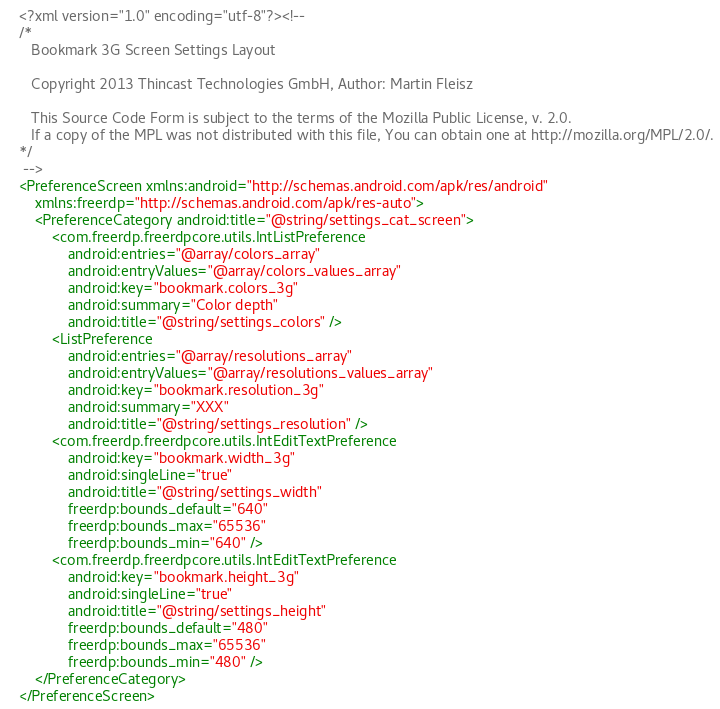<code> <loc_0><loc_0><loc_500><loc_500><_XML_><?xml version="1.0" encoding="utf-8"?><!--
/*
   Bookmark 3G Screen Settings Layout

   Copyright 2013 Thincast Technologies GmbH, Author: Martin Fleisz

   This Source Code Form is subject to the terms of the Mozilla Public License, v. 2.0. 
   If a copy of the MPL was not distributed with this file, You can obtain one at http://mozilla.org/MPL/2.0/.
*/
 -->
<PreferenceScreen xmlns:android="http://schemas.android.com/apk/res/android"
    xmlns:freerdp="http://schemas.android.com/apk/res-auto">
    <PreferenceCategory android:title="@string/settings_cat_screen">
        <com.freerdp.freerdpcore.utils.IntListPreference
            android:entries="@array/colors_array"
            android:entryValues="@array/colors_values_array"
            android:key="bookmark.colors_3g"
            android:summary="Color depth"
            android:title="@string/settings_colors" />
        <ListPreference
            android:entries="@array/resolutions_array"
            android:entryValues="@array/resolutions_values_array"
            android:key="bookmark.resolution_3g"
            android:summary="XXX"
            android:title="@string/settings_resolution" />
        <com.freerdp.freerdpcore.utils.IntEditTextPreference
            android:key="bookmark.width_3g"
            android:singleLine="true"
            android:title="@string/settings_width"
            freerdp:bounds_default="640"
            freerdp:bounds_max="65536"
            freerdp:bounds_min="640" />
        <com.freerdp.freerdpcore.utils.IntEditTextPreference
            android:key="bookmark.height_3g"
            android:singleLine="true"
            android:title="@string/settings_height"
            freerdp:bounds_default="480"
            freerdp:bounds_max="65536"
            freerdp:bounds_min="480" />
    </PreferenceCategory>
</PreferenceScreen>
</code> 